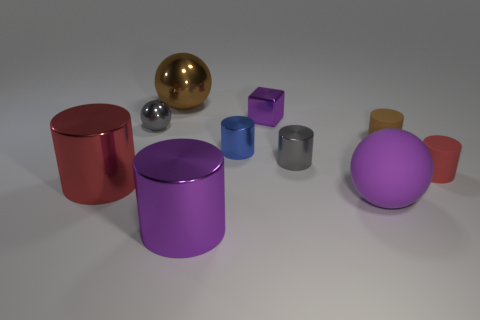Is the number of brown balls right of the purple metallic cylinder less than the number of rubber balls left of the large purple matte ball?
Your answer should be compact. No. Is the size of the brown shiny thing the same as the gray object that is left of the metal cube?
Offer a very short reply. No. What number of purple balls are the same size as the brown sphere?
Make the answer very short. 1. How many tiny objects are either purple shiny cylinders or brown blocks?
Your answer should be very brief. 0. Are there any large red shiny things?
Your answer should be very brief. Yes. Is the number of small brown things to the left of the purple shiny cylinder greater than the number of small gray metal objects that are right of the tiny brown matte thing?
Provide a succinct answer. No. There is a large thing that is behind the small ball on the left side of the tiny brown thing; what is its color?
Offer a very short reply. Brown. Are there any metallic balls that have the same color as the big matte sphere?
Offer a terse response. No. There is a red matte cylinder that is on the right side of the large cylinder to the left of the purple object in front of the purple matte sphere; how big is it?
Give a very brief answer. Small. The big red shiny object has what shape?
Keep it short and to the point. Cylinder. 